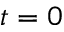<formula> <loc_0><loc_0><loc_500><loc_500>t = 0</formula> 